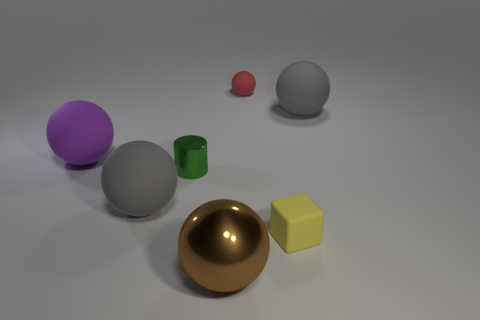Subtract all large balls. How many balls are left? 1 Add 2 large purple rubber things. How many objects exist? 9 Subtract all brown spheres. How many spheres are left? 4 Subtract all gray blocks. How many gray balls are left? 2 Subtract all cylinders. How many objects are left? 6 Subtract 1 cylinders. How many cylinders are left? 0 Subtract all brown blocks. Subtract all cyan spheres. How many blocks are left? 1 Subtract all small blue matte cylinders. Subtract all large purple matte balls. How many objects are left? 6 Add 7 brown metallic balls. How many brown metallic balls are left? 8 Add 1 rubber spheres. How many rubber spheres exist? 5 